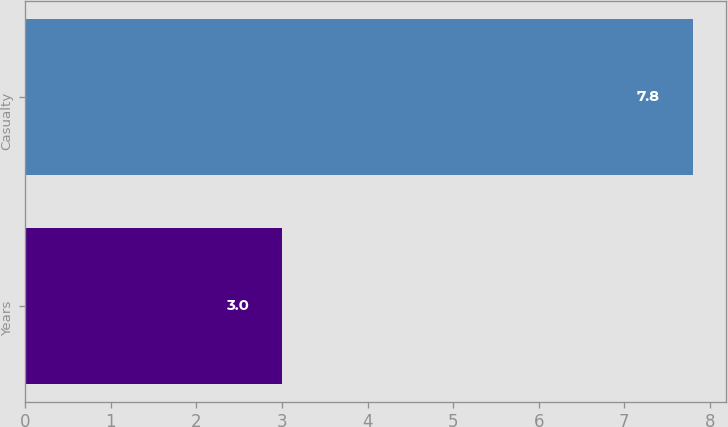Convert chart to OTSL. <chart><loc_0><loc_0><loc_500><loc_500><bar_chart><fcel>Years<fcel>Casualty<nl><fcel>3<fcel>7.8<nl></chart> 